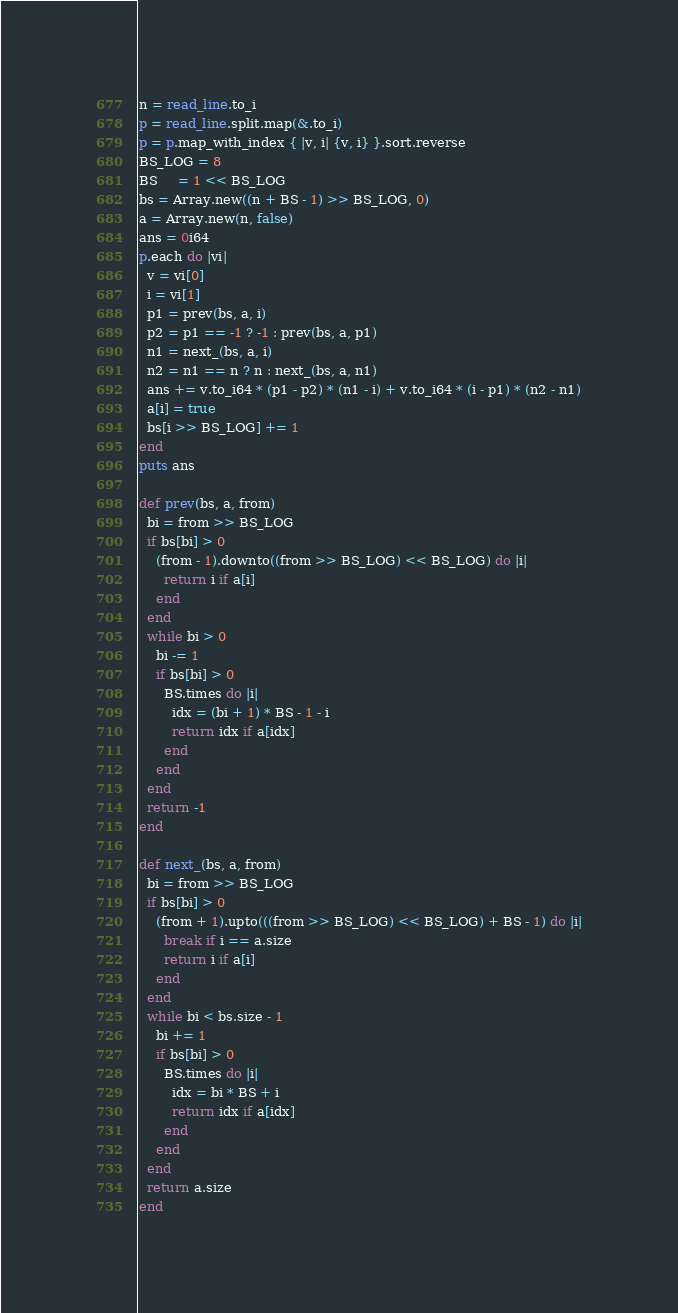Convert code to text. <code><loc_0><loc_0><loc_500><loc_500><_Crystal_>n = read_line.to_i
p = read_line.split.map(&.to_i)
p = p.map_with_index { |v, i| {v, i} }.sort.reverse
BS_LOG = 8
BS     = 1 << BS_LOG
bs = Array.new((n + BS - 1) >> BS_LOG, 0)
a = Array.new(n, false)
ans = 0i64
p.each do |vi|
  v = vi[0]
  i = vi[1]
  p1 = prev(bs, a, i)
  p2 = p1 == -1 ? -1 : prev(bs, a, p1)
  n1 = next_(bs, a, i)
  n2 = n1 == n ? n : next_(bs, a, n1)
  ans += v.to_i64 * (p1 - p2) * (n1 - i) + v.to_i64 * (i - p1) * (n2 - n1)
  a[i] = true
  bs[i >> BS_LOG] += 1
end
puts ans

def prev(bs, a, from)
  bi = from >> BS_LOG
  if bs[bi] > 0
    (from - 1).downto((from >> BS_LOG) << BS_LOG) do |i|
      return i if a[i]
    end
  end
  while bi > 0
    bi -= 1
    if bs[bi] > 0
      BS.times do |i|
        idx = (bi + 1) * BS - 1 - i
        return idx if a[idx]
      end
    end
  end
  return -1
end

def next_(bs, a, from)
  bi = from >> BS_LOG
  if bs[bi] > 0
    (from + 1).upto(((from >> BS_LOG) << BS_LOG) + BS - 1) do |i|
      break if i == a.size
      return i if a[i]
    end
  end
  while bi < bs.size - 1
    bi += 1
    if bs[bi] > 0
      BS.times do |i|
        idx = bi * BS + i
        return idx if a[idx]
      end
    end
  end
  return a.size
end
</code> 